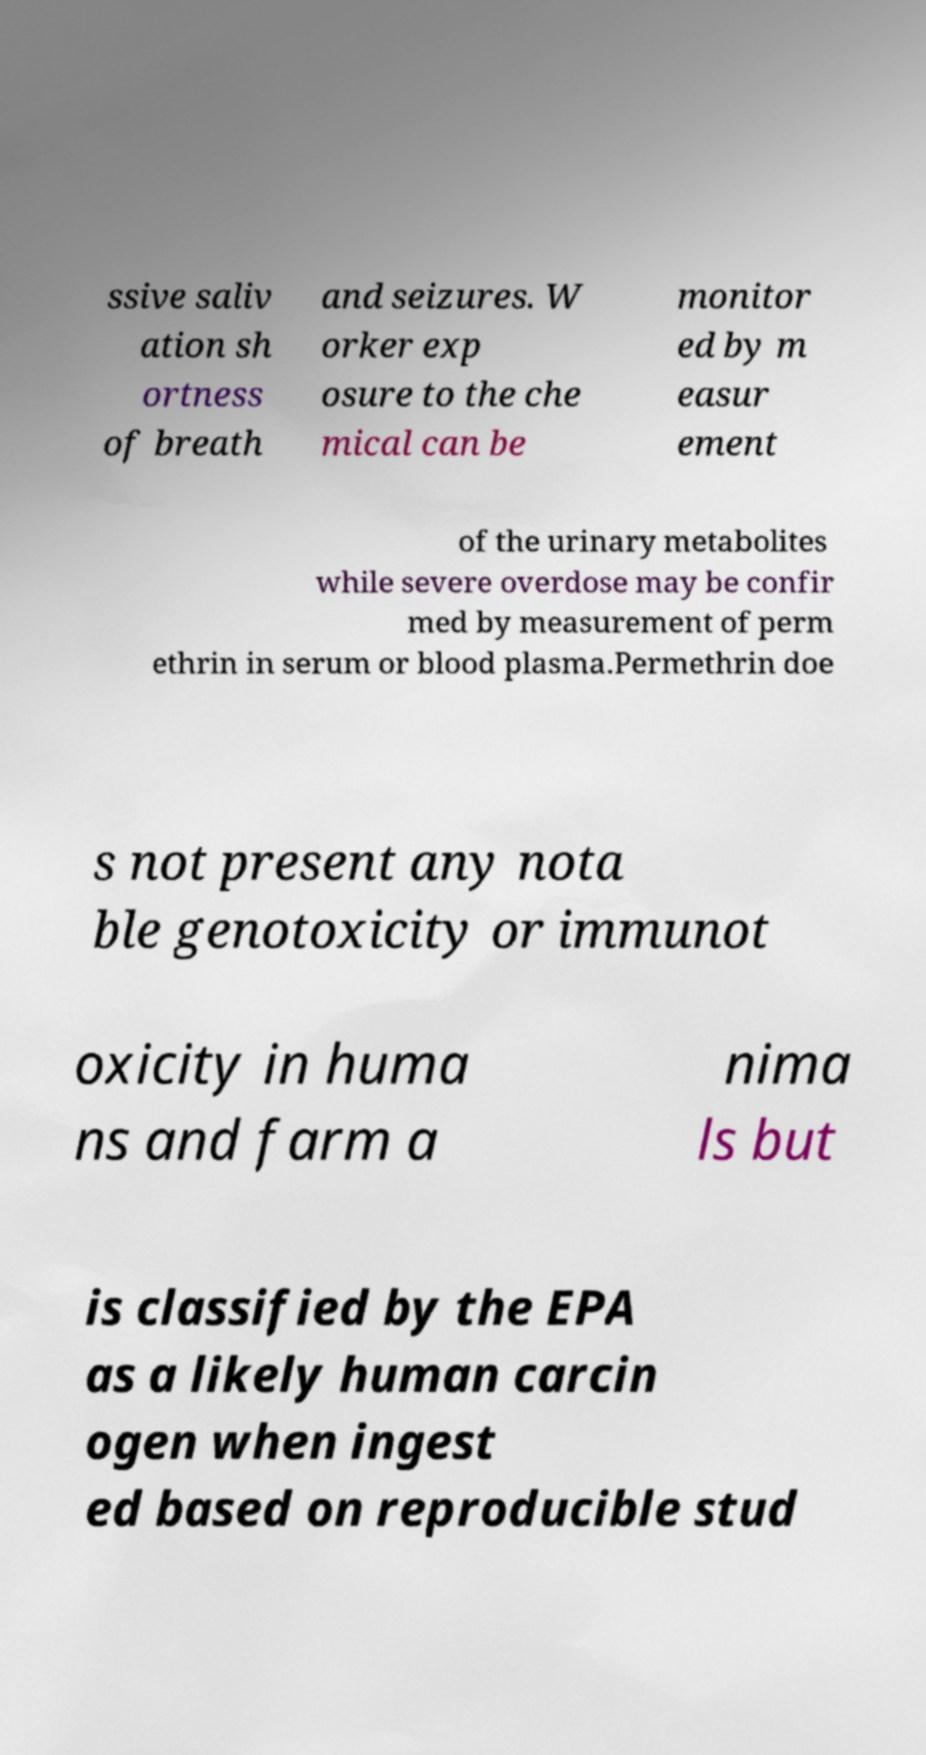For documentation purposes, I need the text within this image transcribed. Could you provide that? ssive saliv ation sh ortness of breath and seizures. W orker exp osure to the che mical can be monitor ed by m easur ement of the urinary metabolites while severe overdose may be confir med by measurement of perm ethrin in serum or blood plasma.Permethrin doe s not present any nota ble genotoxicity or immunot oxicity in huma ns and farm a nima ls but is classified by the EPA as a likely human carcin ogen when ingest ed based on reproducible stud 